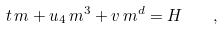<formula> <loc_0><loc_0><loc_500><loc_500>t \, m + u _ { 4 } \, m ^ { 3 } + v \, m ^ { d } = H \quad ,</formula> 